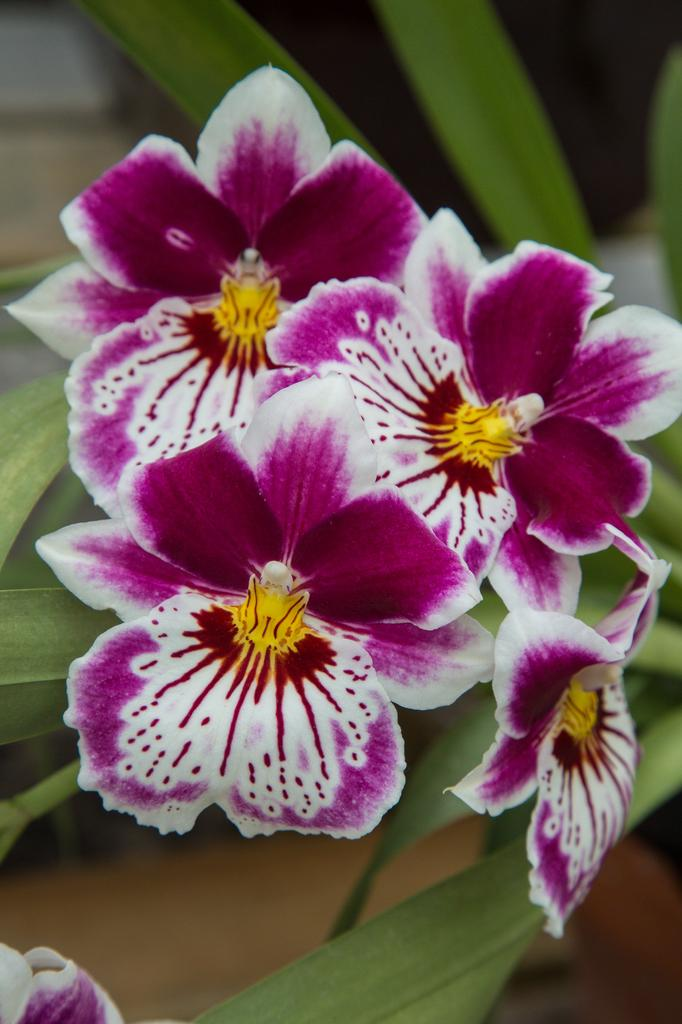What types of plants are visible in the foreground of the image? There are flowers and green leaves in the foreground of the image. What object can be seen in the foreground of the image, resembling a piece of furniture? There is an object that resembles a table in the foreground of the image. Where is the mom sitting with her basket of spades in the image? There is no mom, basket, or spades present in the image. 